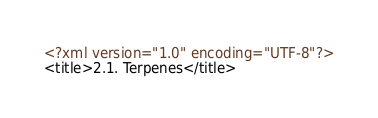Convert code to text. <code><loc_0><loc_0><loc_500><loc_500><_XML_><?xml version="1.0" encoding="UTF-8"?>
<title>2.1. Terpenes</title>
</code> 